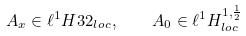Convert formula to latex. <formula><loc_0><loc_0><loc_500><loc_500>A _ { x } \in \ell ^ { 1 } H ^ { } { 3 } 2 _ { l o c } , \quad A _ { 0 } \in \ell ^ { 1 } H ^ { 1 , \frac { 1 } { 2 } } _ { l o c }</formula> 